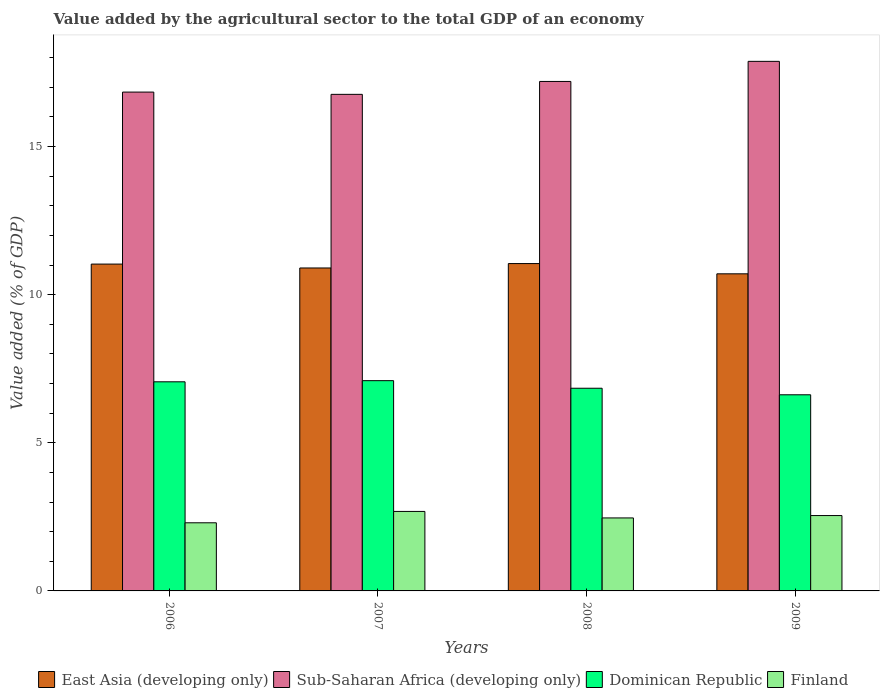How many different coloured bars are there?
Make the answer very short. 4. How many groups of bars are there?
Make the answer very short. 4. How many bars are there on the 2nd tick from the left?
Ensure brevity in your answer.  4. How many bars are there on the 3rd tick from the right?
Your response must be concise. 4. What is the label of the 1st group of bars from the left?
Offer a terse response. 2006. In how many cases, is the number of bars for a given year not equal to the number of legend labels?
Your answer should be compact. 0. What is the value added by the agricultural sector to the total GDP in Dominican Republic in 2006?
Your answer should be very brief. 7.06. Across all years, what is the maximum value added by the agricultural sector to the total GDP in East Asia (developing only)?
Provide a short and direct response. 11.05. Across all years, what is the minimum value added by the agricultural sector to the total GDP in Sub-Saharan Africa (developing only)?
Keep it short and to the point. 16.76. In which year was the value added by the agricultural sector to the total GDP in Sub-Saharan Africa (developing only) maximum?
Your response must be concise. 2009. What is the total value added by the agricultural sector to the total GDP in Sub-Saharan Africa (developing only) in the graph?
Provide a short and direct response. 68.67. What is the difference between the value added by the agricultural sector to the total GDP in East Asia (developing only) in 2006 and that in 2008?
Your answer should be very brief. -0.02. What is the difference between the value added by the agricultural sector to the total GDP in Sub-Saharan Africa (developing only) in 2009 and the value added by the agricultural sector to the total GDP in East Asia (developing only) in 2006?
Offer a very short reply. 6.84. What is the average value added by the agricultural sector to the total GDP in East Asia (developing only) per year?
Offer a terse response. 10.92. In the year 2009, what is the difference between the value added by the agricultural sector to the total GDP in East Asia (developing only) and value added by the agricultural sector to the total GDP in Finland?
Your answer should be very brief. 8.16. What is the ratio of the value added by the agricultural sector to the total GDP in Dominican Republic in 2006 to that in 2009?
Make the answer very short. 1.07. Is the value added by the agricultural sector to the total GDP in Dominican Republic in 2007 less than that in 2009?
Keep it short and to the point. No. Is the difference between the value added by the agricultural sector to the total GDP in East Asia (developing only) in 2007 and 2009 greater than the difference between the value added by the agricultural sector to the total GDP in Finland in 2007 and 2009?
Give a very brief answer. Yes. What is the difference between the highest and the second highest value added by the agricultural sector to the total GDP in Sub-Saharan Africa (developing only)?
Ensure brevity in your answer.  0.68. What is the difference between the highest and the lowest value added by the agricultural sector to the total GDP in Sub-Saharan Africa (developing only)?
Give a very brief answer. 1.11. In how many years, is the value added by the agricultural sector to the total GDP in East Asia (developing only) greater than the average value added by the agricultural sector to the total GDP in East Asia (developing only) taken over all years?
Offer a terse response. 2. Is the sum of the value added by the agricultural sector to the total GDP in Dominican Republic in 2006 and 2008 greater than the maximum value added by the agricultural sector to the total GDP in Finland across all years?
Make the answer very short. Yes. Is it the case that in every year, the sum of the value added by the agricultural sector to the total GDP in Sub-Saharan Africa (developing only) and value added by the agricultural sector to the total GDP in East Asia (developing only) is greater than the sum of value added by the agricultural sector to the total GDP in Finland and value added by the agricultural sector to the total GDP in Dominican Republic?
Offer a very short reply. Yes. What does the 2nd bar from the left in 2006 represents?
Offer a terse response. Sub-Saharan Africa (developing only). What does the 2nd bar from the right in 2008 represents?
Make the answer very short. Dominican Republic. How many bars are there?
Make the answer very short. 16. Are all the bars in the graph horizontal?
Offer a very short reply. No. How many years are there in the graph?
Your answer should be compact. 4. What is the difference between two consecutive major ticks on the Y-axis?
Offer a terse response. 5. Are the values on the major ticks of Y-axis written in scientific E-notation?
Ensure brevity in your answer.  No. Does the graph contain any zero values?
Your response must be concise. No. Does the graph contain grids?
Your answer should be compact. No. Where does the legend appear in the graph?
Your response must be concise. Bottom center. How many legend labels are there?
Your answer should be very brief. 4. How are the legend labels stacked?
Keep it short and to the point. Horizontal. What is the title of the graph?
Make the answer very short. Value added by the agricultural sector to the total GDP of an economy. What is the label or title of the X-axis?
Your response must be concise. Years. What is the label or title of the Y-axis?
Your answer should be very brief. Value added (% of GDP). What is the Value added (% of GDP) of East Asia (developing only) in 2006?
Provide a short and direct response. 11.03. What is the Value added (% of GDP) in Sub-Saharan Africa (developing only) in 2006?
Ensure brevity in your answer.  16.84. What is the Value added (% of GDP) of Dominican Republic in 2006?
Provide a succinct answer. 7.06. What is the Value added (% of GDP) of Finland in 2006?
Offer a very short reply. 2.3. What is the Value added (% of GDP) of East Asia (developing only) in 2007?
Offer a very short reply. 10.9. What is the Value added (% of GDP) in Sub-Saharan Africa (developing only) in 2007?
Keep it short and to the point. 16.76. What is the Value added (% of GDP) of Dominican Republic in 2007?
Your answer should be very brief. 7.1. What is the Value added (% of GDP) in Finland in 2007?
Your response must be concise. 2.68. What is the Value added (% of GDP) in East Asia (developing only) in 2008?
Ensure brevity in your answer.  11.05. What is the Value added (% of GDP) of Sub-Saharan Africa (developing only) in 2008?
Ensure brevity in your answer.  17.2. What is the Value added (% of GDP) in Dominican Republic in 2008?
Keep it short and to the point. 6.84. What is the Value added (% of GDP) of Finland in 2008?
Your answer should be very brief. 2.46. What is the Value added (% of GDP) in East Asia (developing only) in 2009?
Give a very brief answer. 10.7. What is the Value added (% of GDP) of Sub-Saharan Africa (developing only) in 2009?
Your answer should be compact. 17.87. What is the Value added (% of GDP) in Dominican Republic in 2009?
Make the answer very short. 6.62. What is the Value added (% of GDP) of Finland in 2009?
Keep it short and to the point. 2.54. Across all years, what is the maximum Value added (% of GDP) of East Asia (developing only)?
Give a very brief answer. 11.05. Across all years, what is the maximum Value added (% of GDP) in Sub-Saharan Africa (developing only)?
Your answer should be very brief. 17.87. Across all years, what is the maximum Value added (% of GDP) of Dominican Republic?
Provide a succinct answer. 7.1. Across all years, what is the maximum Value added (% of GDP) of Finland?
Ensure brevity in your answer.  2.68. Across all years, what is the minimum Value added (% of GDP) of East Asia (developing only)?
Offer a very short reply. 10.7. Across all years, what is the minimum Value added (% of GDP) of Sub-Saharan Africa (developing only)?
Ensure brevity in your answer.  16.76. Across all years, what is the minimum Value added (% of GDP) of Dominican Republic?
Keep it short and to the point. 6.62. Across all years, what is the minimum Value added (% of GDP) in Finland?
Your answer should be very brief. 2.3. What is the total Value added (% of GDP) in East Asia (developing only) in the graph?
Provide a short and direct response. 43.68. What is the total Value added (% of GDP) in Sub-Saharan Africa (developing only) in the graph?
Offer a very short reply. 68.67. What is the total Value added (% of GDP) in Dominican Republic in the graph?
Make the answer very short. 27.62. What is the total Value added (% of GDP) in Finland in the graph?
Provide a short and direct response. 9.99. What is the difference between the Value added (% of GDP) of East Asia (developing only) in 2006 and that in 2007?
Your response must be concise. 0.13. What is the difference between the Value added (% of GDP) in Sub-Saharan Africa (developing only) in 2006 and that in 2007?
Give a very brief answer. 0.08. What is the difference between the Value added (% of GDP) of Dominican Republic in 2006 and that in 2007?
Provide a short and direct response. -0.04. What is the difference between the Value added (% of GDP) in Finland in 2006 and that in 2007?
Provide a short and direct response. -0.38. What is the difference between the Value added (% of GDP) in East Asia (developing only) in 2006 and that in 2008?
Your answer should be very brief. -0.02. What is the difference between the Value added (% of GDP) of Sub-Saharan Africa (developing only) in 2006 and that in 2008?
Keep it short and to the point. -0.36. What is the difference between the Value added (% of GDP) of Dominican Republic in 2006 and that in 2008?
Your response must be concise. 0.22. What is the difference between the Value added (% of GDP) in Finland in 2006 and that in 2008?
Your response must be concise. -0.16. What is the difference between the Value added (% of GDP) in East Asia (developing only) in 2006 and that in 2009?
Your answer should be compact. 0.33. What is the difference between the Value added (% of GDP) of Sub-Saharan Africa (developing only) in 2006 and that in 2009?
Give a very brief answer. -1.04. What is the difference between the Value added (% of GDP) of Dominican Republic in 2006 and that in 2009?
Offer a very short reply. 0.44. What is the difference between the Value added (% of GDP) of Finland in 2006 and that in 2009?
Offer a terse response. -0.24. What is the difference between the Value added (% of GDP) of East Asia (developing only) in 2007 and that in 2008?
Offer a terse response. -0.15. What is the difference between the Value added (% of GDP) of Sub-Saharan Africa (developing only) in 2007 and that in 2008?
Ensure brevity in your answer.  -0.44. What is the difference between the Value added (% of GDP) in Dominican Republic in 2007 and that in 2008?
Your answer should be very brief. 0.26. What is the difference between the Value added (% of GDP) of Finland in 2007 and that in 2008?
Make the answer very short. 0.22. What is the difference between the Value added (% of GDP) in East Asia (developing only) in 2007 and that in 2009?
Ensure brevity in your answer.  0.2. What is the difference between the Value added (% of GDP) of Sub-Saharan Africa (developing only) in 2007 and that in 2009?
Provide a succinct answer. -1.11. What is the difference between the Value added (% of GDP) in Dominican Republic in 2007 and that in 2009?
Your response must be concise. 0.48. What is the difference between the Value added (% of GDP) of Finland in 2007 and that in 2009?
Give a very brief answer. 0.14. What is the difference between the Value added (% of GDP) in East Asia (developing only) in 2008 and that in 2009?
Give a very brief answer. 0.35. What is the difference between the Value added (% of GDP) in Sub-Saharan Africa (developing only) in 2008 and that in 2009?
Provide a short and direct response. -0.68. What is the difference between the Value added (% of GDP) of Dominican Republic in 2008 and that in 2009?
Offer a very short reply. 0.22. What is the difference between the Value added (% of GDP) in Finland in 2008 and that in 2009?
Your response must be concise. -0.08. What is the difference between the Value added (% of GDP) of East Asia (developing only) in 2006 and the Value added (% of GDP) of Sub-Saharan Africa (developing only) in 2007?
Offer a very short reply. -5.73. What is the difference between the Value added (% of GDP) in East Asia (developing only) in 2006 and the Value added (% of GDP) in Dominican Republic in 2007?
Your response must be concise. 3.93. What is the difference between the Value added (% of GDP) of East Asia (developing only) in 2006 and the Value added (% of GDP) of Finland in 2007?
Provide a succinct answer. 8.35. What is the difference between the Value added (% of GDP) of Sub-Saharan Africa (developing only) in 2006 and the Value added (% of GDP) of Dominican Republic in 2007?
Ensure brevity in your answer.  9.74. What is the difference between the Value added (% of GDP) of Sub-Saharan Africa (developing only) in 2006 and the Value added (% of GDP) of Finland in 2007?
Your answer should be very brief. 14.15. What is the difference between the Value added (% of GDP) in Dominican Republic in 2006 and the Value added (% of GDP) in Finland in 2007?
Offer a terse response. 4.38. What is the difference between the Value added (% of GDP) of East Asia (developing only) in 2006 and the Value added (% of GDP) of Sub-Saharan Africa (developing only) in 2008?
Provide a succinct answer. -6.16. What is the difference between the Value added (% of GDP) in East Asia (developing only) in 2006 and the Value added (% of GDP) in Dominican Republic in 2008?
Make the answer very short. 4.19. What is the difference between the Value added (% of GDP) in East Asia (developing only) in 2006 and the Value added (% of GDP) in Finland in 2008?
Provide a succinct answer. 8.57. What is the difference between the Value added (% of GDP) in Sub-Saharan Africa (developing only) in 2006 and the Value added (% of GDP) in Dominican Republic in 2008?
Ensure brevity in your answer.  10. What is the difference between the Value added (% of GDP) in Sub-Saharan Africa (developing only) in 2006 and the Value added (% of GDP) in Finland in 2008?
Your answer should be compact. 14.37. What is the difference between the Value added (% of GDP) in Dominican Republic in 2006 and the Value added (% of GDP) in Finland in 2008?
Offer a terse response. 4.59. What is the difference between the Value added (% of GDP) of East Asia (developing only) in 2006 and the Value added (% of GDP) of Sub-Saharan Africa (developing only) in 2009?
Give a very brief answer. -6.84. What is the difference between the Value added (% of GDP) of East Asia (developing only) in 2006 and the Value added (% of GDP) of Dominican Republic in 2009?
Keep it short and to the point. 4.41. What is the difference between the Value added (% of GDP) in East Asia (developing only) in 2006 and the Value added (% of GDP) in Finland in 2009?
Keep it short and to the point. 8.49. What is the difference between the Value added (% of GDP) of Sub-Saharan Africa (developing only) in 2006 and the Value added (% of GDP) of Dominican Republic in 2009?
Provide a short and direct response. 10.22. What is the difference between the Value added (% of GDP) in Sub-Saharan Africa (developing only) in 2006 and the Value added (% of GDP) in Finland in 2009?
Your answer should be very brief. 14.29. What is the difference between the Value added (% of GDP) in Dominican Republic in 2006 and the Value added (% of GDP) in Finland in 2009?
Give a very brief answer. 4.51. What is the difference between the Value added (% of GDP) of East Asia (developing only) in 2007 and the Value added (% of GDP) of Sub-Saharan Africa (developing only) in 2008?
Your answer should be compact. -6.3. What is the difference between the Value added (% of GDP) in East Asia (developing only) in 2007 and the Value added (% of GDP) in Dominican Republic in 2008?
Offer a terse response. 4.06. What is the difference between the Value added (% of GDP) of East Asia (developing only) in 2007 and the Value added (% of GDP) of Finland in 2008?
Offer a very short reply. 8.44. What is the difference between the Value added (% of GDP) of Sub-Saharan Africa (developing only) in 2007 and the Value added (% of GDP) of Dominican Republic in 2008?
Ensure brevity in your answer.  9.92. What is the difference between the Value added (% of GDP) in Sub-Saharan Africa (developing only) in 2007 and the Value added (% of GDP) in Finland in 2008?
Ensure brevity in your answer.  14.3. What is the difference between the Value added (% of GDP) in Dominican Republic in 2007 and the Value added (% of GDP) in Finland in 2008?
Keep it short and to the point. 4.63. What is the difference between the Value added (% of GDP) in East Asia (developing only) in 2007 and the Value added (% of GDP) in Sub-Saharan Africa (developing only) in 2009?
Give a very brief answer. -6.97. What is the difference between the Value added (% of GDP) in East Asia (developing only) in 2007 and the Value added (% of GDP) in Dominican Republic in 2009?
Ensure brevity in your answer.  4.28. What is the difference between the Value added (% of GDP) of East Asia (developing only) in 2007 and the Value added (% of GDP) of Finland in 2009?
Offer a very short reply. 8.36. What is the difference between the Value added (% of GDP) in Sub-Saharan Africa (developing only) in 2007 and the Value added (% of GDP) in Dominican Republic in 2009?
Ensure brevity in your answer.  10.14. What is the difference between the Value added (% of GDP) of Sub-Saharan Africa (developing only) in 2007 and the Value added (% of GDP) of Finland in 2009?
Offer a very short reply. 14.22. What is the difference between the Value added (% of GDP) in Dominican Republic in 2007 and the Value added (% of GDP) in Finland in 2009?
Offer a very short reply. 4.55. What is the difference between the Value added (% of GDP) in East Asia (developing only) in 2008 and the Value added (% of GDP) in Sub-Saharan Africa (developing only) in 2009?
Make the answer very short. -6.83. What is the difference between the Value added (% of GDP) of East Asia (developing only) in 2008 and the Value added (% of GDP) of Dominican Republic in 2009?
Provide a short and direct response. 4.43. What is the difference between the Value added (% of GDP) in East Asia (developing only) in 2008 and the Value added (% of GDP) in Finland in 2009?
Provide a short and direct response. 8.51. What is the difference between the Value added (% of GDP) in Sub-Saharan Africa (developing only) in 2008 and the Value added (% of GDP) in Dominican Republic in 2009?
Provide a succinct answer. 10.58. What is the difference between the Value added (% of GDP) of Sub-Saharan Africa (developing only) in 2008 and the Value added (% of GDP) of Finland in 2009?
Your answer should be very brief. 14.65. What is the difference between the Value added (% of GDP) in Dominican Republic in 2008 and the Value added (% of GDP) in Finland in 2009?
Provide a succinct answer. 4.3. What is the average Value added (% of GDP) in East Asia (developing only) per year?
Your response must be concise. 10.92. What is the average Value added (% of GDP) of Sub-Saharan Africa (developing only) per year?
Ensure brevity in your answer.  17.17. What is the average Value added (% of GDP) in Dominican Republic per year?
Your answer should be very brief. 6.9. What is the average Value added (% of GDP) of Finland per year?
Provide a succinct answer. 2.5. In the year 2006, what is the difference between the Value added (% of GDP) in East Asia (developing only) and Value added (% of GDP) in Sub-Saharan Africa (developing only)?
Offer a very short reply. -5.81. In the year 2006, what is the difference between the Value added (% of GDP) in East Asia (developing only) and Value added (% of GDP) in Dominican Republic?
Your answer should be very brief. 3.97. In the year 2006, what is the difference between the Value added (% of GDP) in East Asia (developing only) and Value added (% of GDP) in Finland?
Ensure brevity in your answer.  8.73. In the year 2006, what is the difference between the Value added (% of GDP) of Sub-Saharan Africa (developing only) and Value added (% of GDP) of Dominican Republic?
Provide a succinct answer. 9.78. In the year 2006, what is the difference between the Value added (% of GDP) in Sub-Saharan Africa (developing only) and Value added (% of GDP) in Finland?
Your answer should be compact. 14.54. In the year 2006, what is the difference between the Value added (% of GDP) of Dominican Republic and Value added (% of GDP) of Finland?
Keep it short and to the point. 4.76. In the year 2007, what is the difference between the Value added (% of GDP) of East Asia (developing only) and Value added (% of GDP) of Sub-Saharan Africa (developing only)?
Your response must be concise. -5.86. In the year 2007, what is the difference between the Value added (% of GDP) of East Asia (developing only) and Value added (% of GDP) of Dominican Republic?
Make the answer very short. 3.8. In the year 2007, what is the difference between the Value added (% of GDP) in East Asia (developing only) and Value added (% of GDP) in Finland?
Ensure brevity in your answer.  8.22. In the year 2007, what is the difference between the Value added (% of GDP) in Sub-Saharan Africa (developing only) and Value added (% of GDP) in Dominican Republic?
Your answer should be very brief. 9.66. In the year 2007, what is the difference between the Value added (% of GDP) in Sub-Saharan Africa (developing only) and Value added (% of GDP) in Finland?
Your answer should be very brief. 14.08. In the year 2007, what is the difference between the Value added (% of GDP) in Dominican Republic and Value added (% of GDP) in Finland?
Your response must be concise. 4.41. In the year 2008, what is the difference between the Value added (% of GDP) in East Asia (developing only) and Value added (% of GDP) in Sub-Saharan Africa (developing only)?
Your answer should be very brief. -6.15. In the year 2008, what is the difference between the Value added (% of GDP) in East Asia (developing only) and Value added (% of GDP) in Dominican Republic?
Ensure brevity in your answer.  4.21. In the year 2008, what is the difference between the Value added (% of GDP) in East Asia (developing only) and Value added (% of GDP) in Finland?
Keep it short and to the point. 8.59. In the year 2008, what is the difference between the Value added (% of GDP) of Sub-Saharan Africa (developing only) and Value added (% of GDP) of Dominican Republic?
Give a very brief answer. 10.35. In the year 2008, what is the difference between the Value added (% of GDP) of Sub-Saharan Africa (developing only) and Value added (% of GDP) of Finland?
Your response must be concise. 14.73. In the year 2008, what is the difference between the Value added (% of GDP) of Dominican Republic and Value added (% of GDP) of Finland?
Offer a very short reply. 4.38. In the year 2009, what is the difference between the Value added (% of GDP) of East Asia (developing only) and Value added (% of GDP) of Sub-Saharan Africa (developing only)?
Ensure brevity in your answer.  -7.17. In the year 2009, what is the difference between the Value added (% of GDP) of East Asia (developing only) and Value added (% of GDP) of Dominican Republic?
Offer a terse response. 4.08. In the year 2009, what is the difference between the Value added (% of GDP) of East Asia (developing only) and Value added (% of GDP) of Finland?
Provide a short and direct response. 8.16. In the year 2009, what is the difference between the Value added (% of GDP) of Sub-Saharan Africa (developing only) and Value added (% of GDP) of Dominican Republic?
Offer a very short reply. 11.25. In the year 2009, what is the difference between the Value added (% of GDP) in Sub-Saharan Africa (developing only) and Value added (% of GDP) in Finland?
Ensure brevity in your answer.  15.33. In the year 2009, what is the difference between the Value added (% of GDP) of Dominican Republic and Value added (% of GDP) of Finland?
Your response must be concise. 4.08. What is the ratio of the Value added (% of GDP) of Dominican Republic in 2006 to that in 2007?
Provide a succinct answer. 0.99. What is the ratio of the Value added (% of GDP) of Finland in 2006 to that in 2007?
Your response must be concise. 0.86. What is the ratio of the Value added (% of GDP) of East Asia (developing only) in 2006 to that in 2008?
Your answer should be very brief. 1. What is the ratio of the Value added (% of GDP) of Sub-Saharan Africa (developing only) in 2006 to that in 2008?
Offer a very short reply. 0.98. What is the ratio of the Value added (% of GDP) in Dominican Republic in 2006 to that in 2008?
Make the answer very short. 1.03. What is the ratio of the Value added (% of GDP) in Finland in 2006 to that in 2008?
Your answer should be very brief. 0.93. What is the ratio of the Value added (% of GDP) in East Asia (developing only) in 2006 to that in 2009?
Keep it short and to the point. 1.03. What is the ratio of the Value added (% of GDP) of Sub-Saharan Africa (developing only) in 2006 to that in 2009?
Your answer should be very brief. 0.94. What is the ratio of the Value added (% of GDP) in Dominican Republic in 2006 to that in 2009?
Offer a terse response. 1.07. What is the ratio of the Value added (% of GDP) in Finland in 2006 to that in 2009?
Your answer should be compact. 0.9. What is the ratio of the Value added (% of GDP) in East Asia (developing only) in 2007 to that in 2008?
Your answer should be compact. 0.99. What is the ratio of the Value added (% of GDP) of Sub-Saharan Africa (developing only) in 2007 to that in 2008?
Provide a short and direct response. 0.97. What is the ratio of the Value added (% of GDP) of Dominican Republic in 2007 to that in 2008?
Your answer should be compact. 1.04. What is the ratio of the Value added (% of GDP) in Finland in 2007 to that in 2008?
Ensure brevity in your answer.  1.09. What is the ratio of the Value added (% of GDP) in East Asia (developing only) in 2007 to that in 2009?
Your answer should be very brief. 1.02. What is the ratio of the Value added (% of GDP) of Sub-Saharan Africa (developing only) in 2007 to that in 2009?
Your answer should be very brief. 0.94. What is the ratio of the Value added (% of GDP) in Dominican Republic in 2007 to that in 2009?
Make the answer very short. 1.07. What is the ratio of the Value added (% of GDP) in Finland in 2007 to that in 2009?
Your answer should be compact. 1.05. What is the ratio of the Value added (% of GDP) of East Asia (developing only) in 2008 to that in 2009?
Give a very brief answer. 1.03. What is the ratio of the Value added (% of GDP) of Sub-Saharan Africa (developing only) in 2008 to that in 2009?
Offer a terse response. 0.96. What is the ratio of the Value added (% of GDP) in Dominican Republic in 2008 to that in 2009?
Give a very brief answer. 1.03. What is the ratio of the Value added (% of GDP) in Finland in 2008 to that in 2009?
Provide a succinct answer. 0.97. What is the difference between the highest and the second highest Value added (% of GDP) in East Asia (developing only)?
Provide a short and direct response. 0.02. What is the difference between the highest and the second highest Value added (% of GDP) in Sub-Saharan Africa (developing only)?
Provide a succinct answer. 0.68. What is the difference between the highest and the second highest Value added (% of GDP) in Dominican Republic?
Make the answer very short. 0.04. What is the difference between the highest and the second highest Value added (% of GDP) in Finland?
Keep it short and to the point. 0.14. What is the difference between the highest and the lowest Value added (% of GDP) of East Asia (developing only)?
Provide a succinct answer. 0.35. What is the difference between the highest and the lowest Value added (% of GDP) in Sub-Saharan Africa (developing only)?
Provide a short and direct response. 1.11. What is the difference between the highest and the lowest Value added (% of GDP) of Dominican Republic?
Your answer should be very brief. 0.48. What is the difference between the highest and the lowest Value added (% of GDP) of Finland?
Keep it short and to the point. 0.38. 